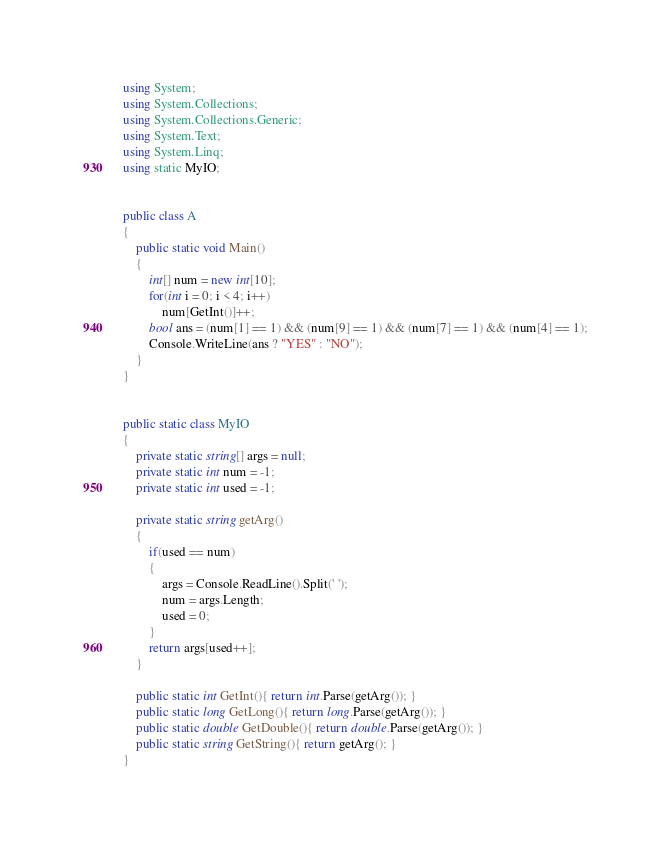Convert code to text. <code><loc_0><loc_0><loc_500><loc_500><_C#_>using System;
using System.Collections;
using System.Collections.Generic;
using System.Text;
using System.Linq;
using static MyIO;


public class A
{
	public static void Main()
	{
		int[] num = new int[10];
		for(int i = 0; i < 4; i++)
			num[GetInt()]++;
		bool ans = (num[1] == 1) && (num[9] == 1) && (num[7] == 1) && (num[4] == 1);
		Console.WriteLine(ans ? "YES" : "NO");
	}
}


public static class MyIO
{
	private static string[] args = null;
	private static int num = -1;
	private static int used = -1;

	private static string getArg()
	{
		if(used == num)
		{
			args = Console.ReadLine().Split(' ');
			num = args.Length;
			used = 0;
		}
		return args[used++];
	}

	public static int GetInt(){ return int.Parse(getArg()); }
	public static long GetLong(){ return long.Parse(getArg()); }
	public static double GetDouble(){ return double.Parse(getArg()); }
	public static string GetString(){ return getArg(); }
}</code> 